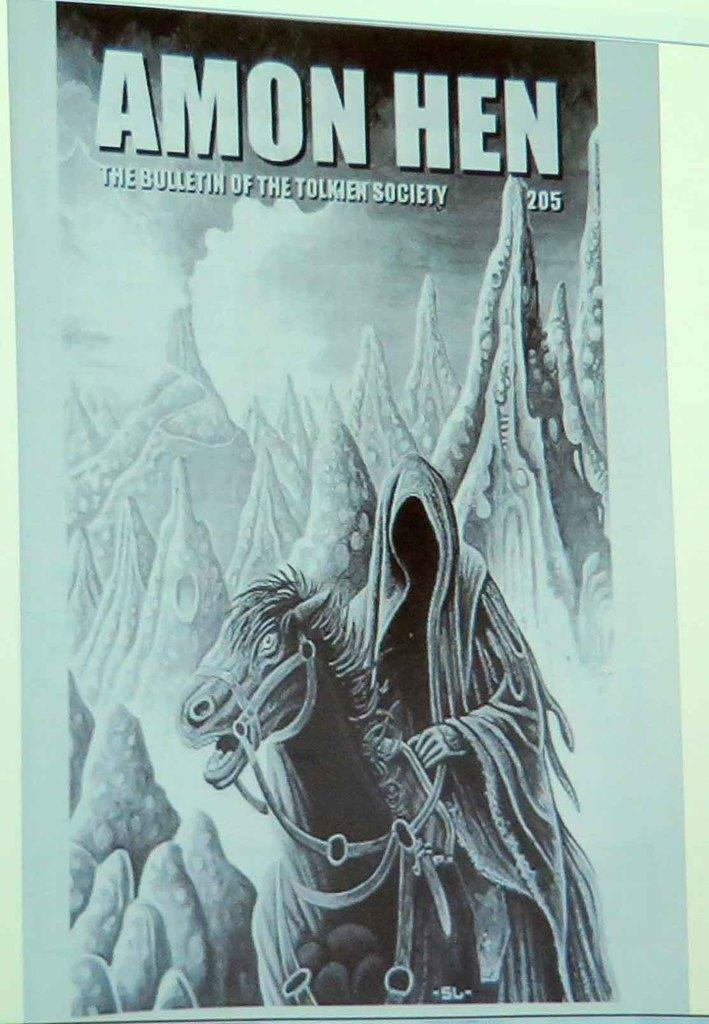What is featured on the poster in the image? The poster contains a horse and a man. What can be seen in the background of the poster? There are mountains in the background of the poster. Is there any text on the poster? Yes, there is text at the top of the poster. What color is the pen used to write on the sofa in the image? There is no pen or sofa present in the image; it only features a poster with a horse, a man, mountains, and text. 